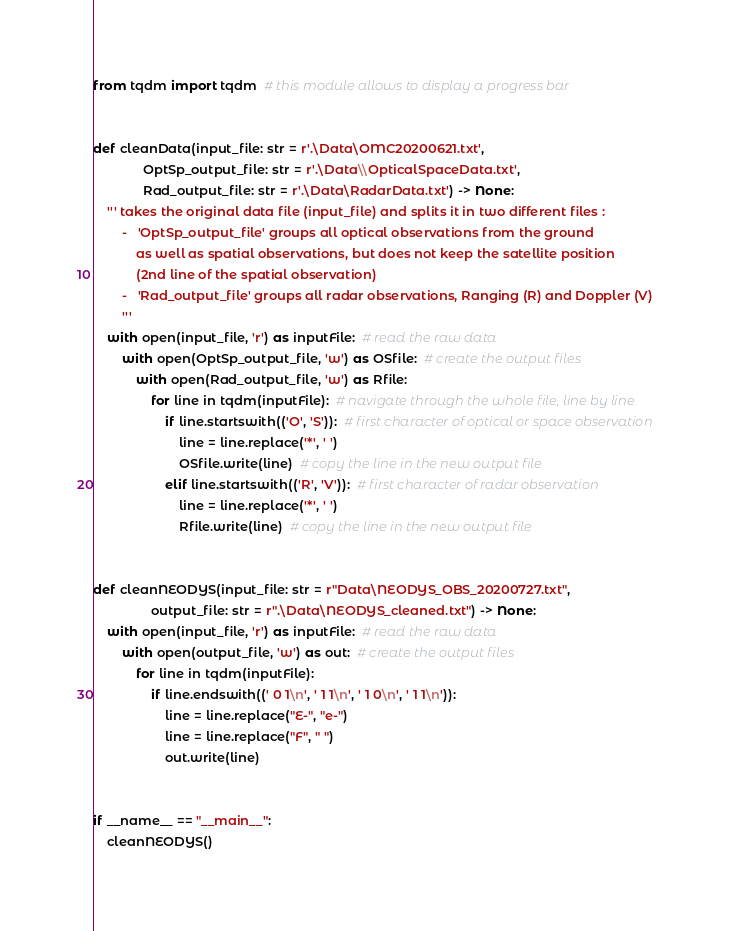Convert code to text. <code><loc_0><loc_0><loc_500><loc_500><_Python_>from tqdm import tqdm  # this module allows to display a progress bar


def cleanData(input_file: str = r'.\Data\OMC20200621.txt',
              OptSp_output_file: str = r'.\Data\\OpticalSpaceData.txt',
              Rad_output_file: str = r'.\Data\RadarData.txt') -> None:
    ''' takes the original data file (input_file) and splits it in two different files :
        -   'OptSp_output_file' groups all optical observations from the ground
            as well as spatial observations, but does not keep the satellite position
            (2nd line of the spatial observation)
        -   'Rad_output_file' groups all radar observations, Ranging (R) and Doppler (V)
        '''
    with open(input_file, 'r') as inputFile:  # read the raw data
        with open(OptSp_output_file, 'w') as OSfile:  # create the output files
            with open(Rad_output_file, 'w') as Rfile:
                for line in tqdm(inputFile):  # navigate through the whole file, line by line
                    if line.startswith(('O', 'S')):  # first character of optical or space observation
                        line = line.replace('*', ' ')
                        OSfile.write(line)  # copy the line in the new output file
                    elif line.startswith(('R', 'V')):  # first character of radar observation
                        line = line.replace('*', ' ')
                        Rfile.write(line)  # copy the line in the new output file


def cleanNEODYS(input_file: str = r"Data\NEODYS_OBS_20200727.txt",
                output_file: str = r".\Data\NEODYS_cleaned.txt") -> None:
    with open(input_file, 'r') as inputFile:  # read the raw data
        with open(output_file, 'w') as out:  # create the output files
            for line in tqdm(inputFile):
                if line.endswith((' 0 1\n', ' 1 1\n', ' 1 0\n', ' 1 1\n')):
                    line = line.replace("E-", "e-")
                    line = line.replace("F", " ")
                    out.write(line)


if __name__ == "__main__":
    cleanNEODYS()
</code> 